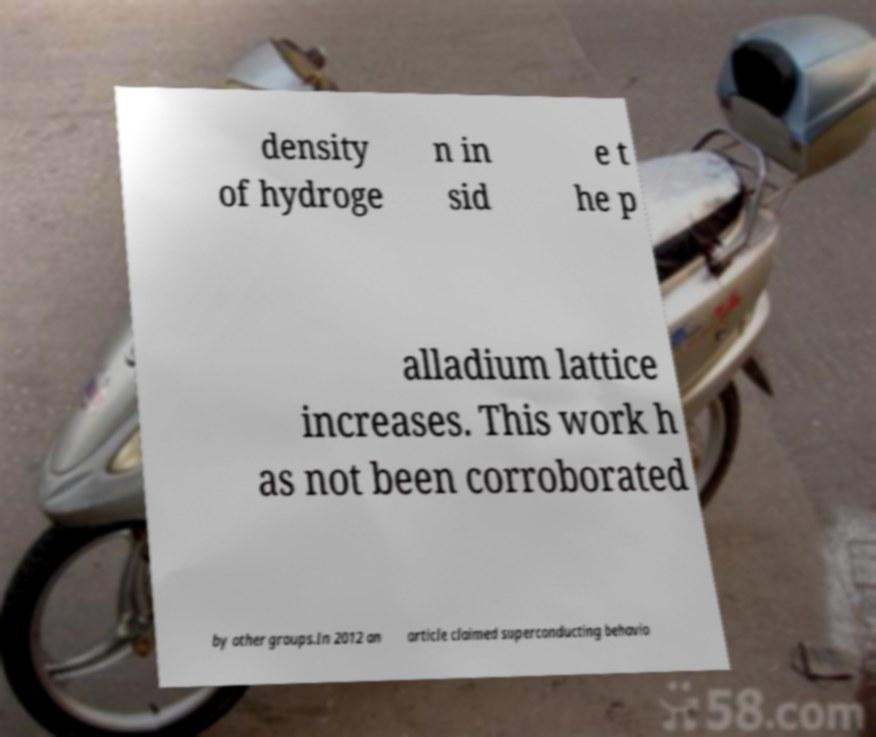For documentation purposes, I need the text within this image transcribed. Could you provide that? density of hydroge n in sid e t he p alladium lattice increases. This work h as not been corroborated by other groups.In 2012 an article claimed superconducting behavio 